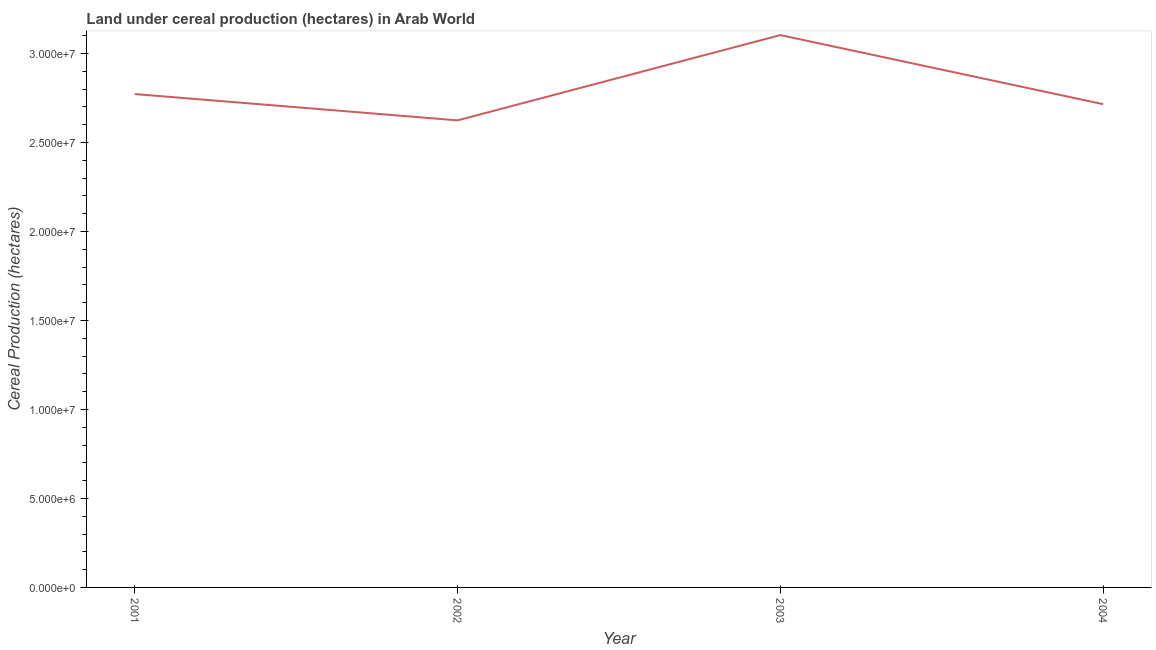What is the land under cereal production in 2001?
Provide a short and direct response. 2.77e+07. Across all years, what is the maximum land under cereal production?
Offer a very short reply. 3.10e+07. Across all years, what is the minimum land under cereal production?
Your answer should be very brief. 2.62e+07. What is the sum of the land under cereal production?
Your answer should be compact. 1.12e+08. What is the difference between the land under cereal production in 2002 and 2004?
Keep it short and to the point. -9.11e+05. What is the average land under cereal production per year?
Ensure brevity in your answer.  2.80e+07. What is the median land under cereal production?
Offer a very short reply. 2.74e+07. What is the ratio of the land under cereal production in 2002 to that in 2004?
Keep it short and to the point. 0.97. Is the land under cereal production in 2001 less than that in 2002?
Keep it short and to the point. No. What is the difference between the highest and the second highest land under cereal production?
Keep it short and to the point. 3.31e+06. What is the difference between the highest and the lowest land under cereal production?
Your response must be concise. 4.79e+06. In how many years, is the land under cereal production greater than the average land under cereal production taken over all years?
Make the answer very short. 1. Does the land under cereal production monotonically increase over the years?
Keep it short and to the point. No. Does the graph contain grids?
Offer a very short reply. No. What is the title of the graph?
Provide a short and direct response. Land under cereal production (hectares) in Arab World. What is the label or title of the Y-axis?
Make the answer very short. Cereal Production (hectares). What is the Cereal Production (hectares) of 2001?
Provide a succinct answer. 2.77e+07. What is the Cereal Production (hectares) of 2002?
Give a very brief answer. 2.62e+07. What is the Cereal Production (hectares) of 2003?
Your response must be concise. 3.10e+07. What is the Cereal Production (hectares) in 2004?
Your answer should be very brief. 2.71e+07. What is the difference between the Cereal Production (hectares) in 2001 and 2002?
Make the answer very short. 1.48e+06. What is the difference between the Cereal Production (hectares) in 2001 and 2003?
Your answer should be compact. -3.31e+06. What is the difference between the Cereal Production (hectares) in 2001 and 2004?
Provide a short and direct response. 5.67e+05. What is the difference between the Cereal Production (hectares) in 2002 and 2003?
Ensure brevity in your answer.  -4.79e+06. What is the difference between the Cereal Production (hectares) in 2002 and 2004?
Ensure brevity in your answer.  -9.11e+05. What is the difference between the Cereal Production (hectares) in 2003 and 2004?
Provide a short and direct response. 3.88e+06. What is the ratio of the Cereal Production (hectares) in 2001 to that in 2002?
Your answer should be compact. 1.06. What is the ratio of the Cereal Production (hectares) in 2001 to that in 2003?
Your response must be concise. 0.89. What is the ratio of the Cereal Production (hectares) in 2002 to that in 2003?
Your response must be concise. 0.85. What is the ratio of the Cereal Production (hectares) in 2002 to that in 2004?
Make the answer very short. 0.97. What is the ratio of the Cereal Production (hectares) in 2003 to that in 2004?
Provide a short and direct response. 1.14. 